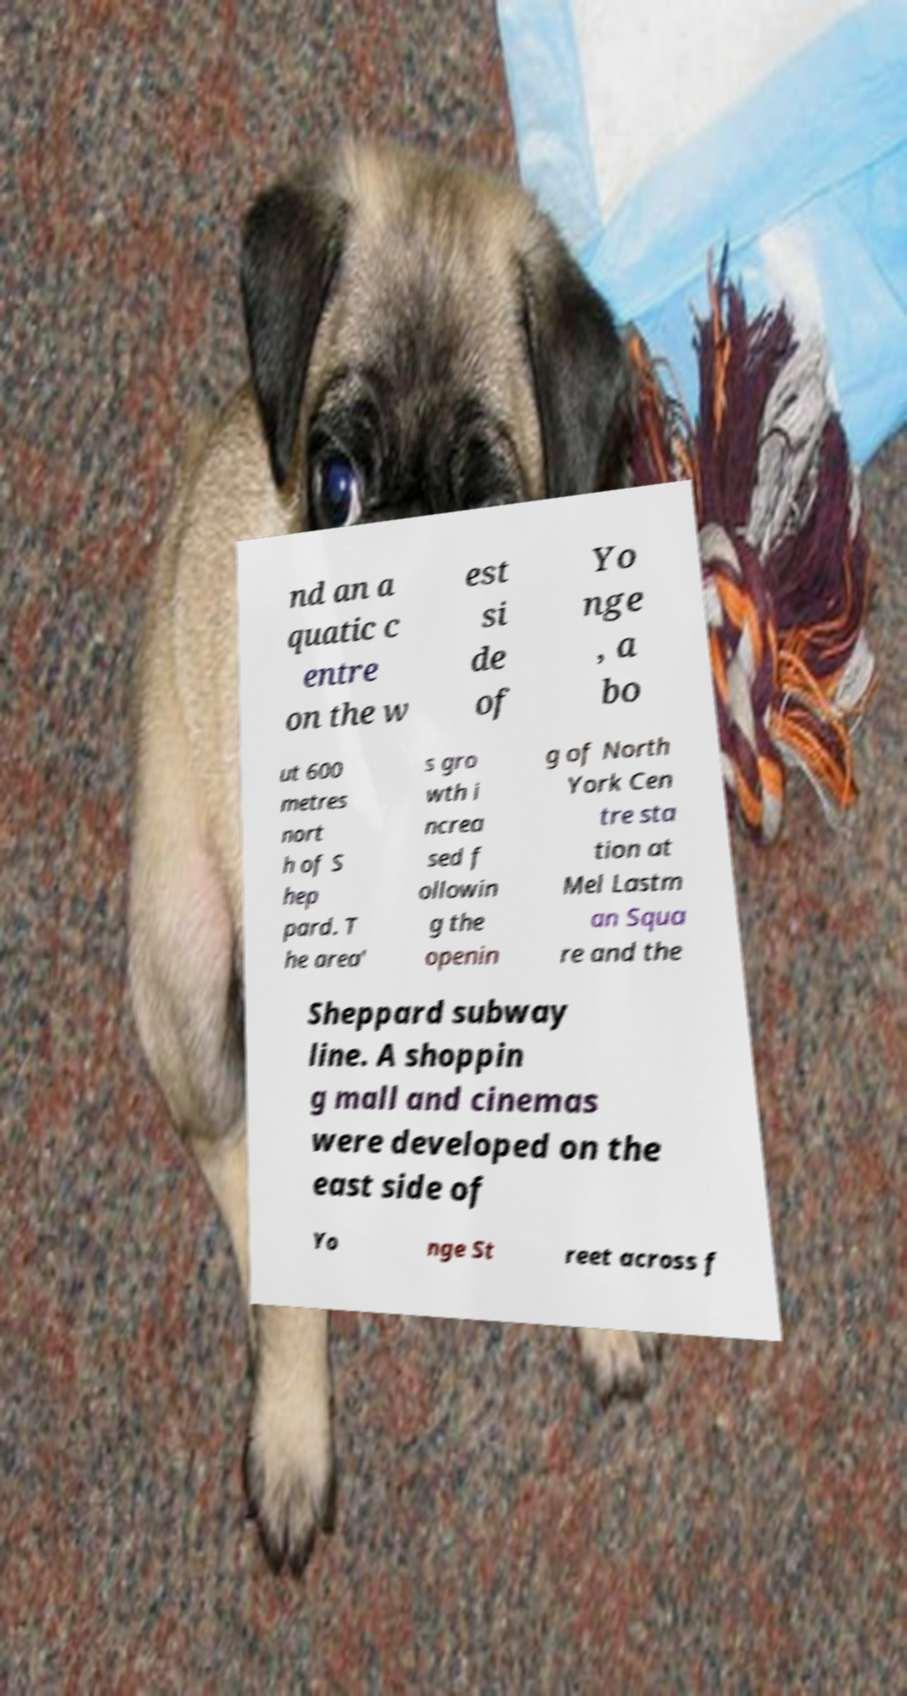Could you assist in decoding the text presented in this image and type it out clearly? nd an a quatic c entre on the w est si de of Yo nge , a bo ut 600 metres nort h of S hep pard. T he area' s gro wth i ncrea sed f ollowin g the openin g of North York Cen tre sta tion at Mel Lastm an Squa re and the Sheppard subway line. A shoppin g mall and cinemas were developed on the east side of Yo nge St reet across f 